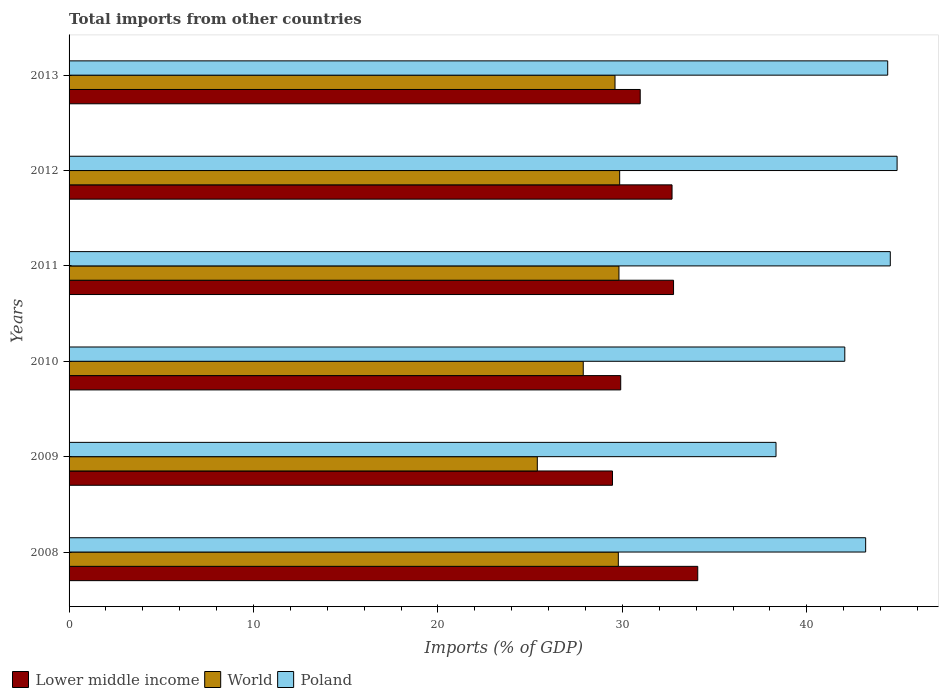How many different coloured bars are there?
Ensure brevity in your answer.  3. How many groups of bars are there?
Make the answer very short. 6. How many bars are there on the 2nd tick from the top?
Keep it short and to the point. 3. How many bars are there on the 3rd tick from the bottom?
Make the answer very short. 3. In how many cases, is the number of bars for a given year not equal to the number of legend labels?
Offer a very short reply. 0. What is the total imports in Lower middle income in 2008?
Provide a short and direct response. 34.09. Across all years, what is the maximum total imports in World?
Offer a very short reply. 29.85. Across all years, what is the minimum total imports in Poland?
Offer a terse response. 38.33. In which year was the total imports in Poland minimum?
Provide a succinct answer. 2009. What is the total total imports in Lower middle income in the graph?
Keep it short and to the point. 189.9. What is the difference between the total imports in World in 2009 and that in 2012?
Provide a succinct answer. -4.47. What is the difference between the total imports in Lower middle income in 2011 and the total imports in World in 2008?
Keep it short and to the point. 2.99. What is the average total imports in Lower middle income per year?
Provide a short and direct response. 31.65. In the year 2012, what is the difference between the total imports in Poland and total imports in World?
Ensure brevity in your answer.  15.04. In how many years, is the total imports in World greater than 16 %?
Give a very brief answer. 6. What is the ratio of the total imports in Lower middle income in 2011 to that in 2013?
Give a very brief answer. 1.06. Is the difference between the total imports in Poland in 2011 and 2012 greater than the difference between the total imports in World in 2011 and 2012?
Your answer should be compact. No. What is the difference between the highest and the second highest total imports in Poland?
Your answer should be compact. 0.37. What is the difference between the highest and the lowest total imports in Poland?
Your answer should be compact. 6.57. Is the sum of the total imports in Lower middle income in 2008 and 2010 greater than the maximum total imports in Poland across all years?
Ensure brevity in your answer.  Yes. What does the 3rd bar from the top in 2013 represents?
Your response must be concise. Lower middle income. Is it the case that in every year, the sum of the total imports in Lower middle income and total imports in World is greater than the total imports in Poland?
Ensure brevity in your answer.  Yes. Are all the bars in the graph horizontal?
Offer a very short reply. Yes. How many years are there in the graph?
Keep it short and to the point. 6. What is the difference between two consecutive major ticks on the X-axis?
Keep it short and to the point. 10. Does the graph contain any zero values?
Keep it short and to the point. No. How are the legend labels stacked?
Ensure brevity in your answer.  Horizontal. What is the title of the graph?
Your answer should be very brief. Total imports from other countries. What is the label or title of the X-axis?
Keep it short and to the point. Imports (% of GDP). What is the label or title of the Y-axis?
Provide a succinct answer. Years. What is the Imports (% of GDP) in Lower middle income in 2008?
Provide a succinct answer. 34.09. What is the Imports (% of GDP) in World in 2008?
Give a very brief answer. 29.78. What is the Imports (% of GDP) of Poland in 2008?
Offer a terse response. 43.19. What is the Imports (% of GDP) in Lower middle income in 2009?
Offer a terse response. 29.46. What is the Imports (% of GDP) of World in 2009?
Your answer should be very brief. 25.39. What is the Imports (% of GDP) of Poland in 2009?
Offer a very short reply. 38.33. What is the Imports (% of GDP) of Lower middle income in 2010?
Your answer should be very brief. 29.91. What is the Imports (% of GDP) of World in 2010?
Ensure brevity in your answer.  27.88. What is the Imports (% of GDP) of Poland in 2010?
Provide a succinct answer. 42.06. What is the Imports (% of GDP) of Lower middle income in 2011?
Offer a very short reply. 32.77. What is the Imports (% of GDP) of World in 2011?
Provide a short and direct response. 29.82. What is the Imports (% of GDP) in Poland in 2011?
Your answer should be compact. 44.53. What is the Imports (% of GDP) in Lower middle income in 2012?
Offer a terse response. 32.69. What is the Imports (% of GDP) of World in 2012?
Provide a short and direct response. 29.85. What is the Imports (% of GDP) in Poland in 2012?
Provide a succinct answer. 44.9. What is the Imports (% of GDP) of Lower middle income in 2013?
Provide a short and direct response. 30.97. What is the Imports (% of GDP) of World in 2013?
Provide a short and direct response. 29.6. What is the Imports (% of GDP) of Poland in 2013?
Provide a short and direct response. 44.39. Across all years, what is the maximum Imports (% of GDP) of Lower middle income?
Your answer should be very brief. 34.09. Across all years, what is the maximum Imports (% of GDP) of World?
Keep it short and to the point. 29.85. Across all years, what is the maximum Imports (% of GDP) in Poland?
Provide a succinct answer. 44.9. Across all years, what is the minimum Imports (% of GDP) in Lower middle income?
Offer a very short reply. 29.46. Across all years, what is the minimum Imports (% of GDP) in World?
Offer a terse response. 25.39. Across all years, what is the minimum Imports (% of GDP) of Poland?
Give a very brief answer. 38.33. What is the total Imports (% of GDP) of Lower middle income in the graph?
Make the answer very short. 189.9. What is the total Imports (% of GDP) in World in the graph?
Your answer should be very brief. 172.32. What is the total Imports (% of GDP) in Poland in the graph?
Ensure brevity in your answer.  257.39. What is the difference between the Imports (% of GDP) of Lower middle income in 2008 and that in 2009?
Keep it short and to the point. 4.62. What is the difference between the Imports (% of GDP) in World in 2008 and that in 2009?
Your answer should be very brief. 4.39. What is the difference between the Imports (% of GDP) in Poland in 2008 and that in 2009?
Your answer should be very brief. 4.86. What is the difference between the Imports (% of GDP) in Lower middle income in 2008 and that in 2010?
Your response must be concise. 4.18. What is the difference between the Imports (% of GDP) in World in 2008 and that in 2010?
Make the answer very short. 1.9. What is the difference between the Imports (% of GDP) in Poland in 2008 and that in 2010?
Your response must be concise. 1.13. What is the difference between the Imports (% of GDP) in Lower middle income in 2008 and that in 2011?
Your answer should be compact. 1.31. What is the difference between the Imports (% of GDP) of World in 2008 and that in 2011?
Give a very brief answer. -0.03. What is the difference between the Imports (% of GDP) in Poland in 2008 and that in 2011?
Offer a terse response. -1.34. What is the difference between the Imports (% of GDP) in Lower middle income in 2008 and that in 2012?
Offer a very short reply. 1.39. What is the difference between the Imports (% of GDP) of World in 2008 and that in 2012?
Ensure brevity in your answer.  -0.07. What is the difference between the Imports (% of GDP) in Poland in 2008 and that in 2012?
Your answer should be compact. -1.7. What is the difference between the Imports (% of GDP) in Lower middle income in 2008 and that in 2013?
Offer a very short reply. 3.12. What is the difference between the Imports (% of GDP) of World in 2008 and that in 2013?
Offer a terse response. 0.18. What is the difference between the Imports (% of GDP) in Poland in 2008 and that in 2013?
Your answer should be very brief. -1.2. What is the difference between the Imports (% of GDP) of Lower middle income in 2009 and that in 2010?
Your response must be concise. -0.45. What is the difference between the Imports (% of GDP) of World in 2009 and that in 2010?
Provide a short and direct response. -2.49. What is the difference between the Imports (% of GDP) in Poland in 2009 and that in 2010?
Your answer should be compact. -3.73. What is the difference between the Imports (% of GDP) of Lower middle income in 2009 and that in 2011?
Ensure brevity in your answer.  -3.31. What is the difference between the Imports (% of GDP) in World in 2009 and that in 2011?
Provide a succinct answer. -4.43. What is the difference between the Imports (% of GDP) in Poland in 2009 and that in 2011?
Give a very brief answer. -6.2. What is the difference between the Imports (% of GDP) of Lower middle income in 2009 and that in 2012?
Offer a terse response. -3.23. What is the difference between the Imports (% of GDP) of World in 2009 and that in 2012?
Give a very brief answer. -4.47. What is the difference between the Imports (% of GDP) of Poland in 2009 and that in 2012?
Make the answer very short. -6.57. What is the difference between the Imports (% of GDP) of Lower middle income in 2009 and that in 2013?
Offer a very short reply. -1.5. What is the difference between the Imports (% of GDP) in World in 2009 and that in 2013?
Provide a succinct answer. -4.21. What is the difference between the Imports (% of GDP) in Poland in 2009 and that in 2013?
Give a very brief answer. -6.06. What is the difference between the Imports (% of GDP) in Lower middle income in 2010 and that in 2011?
Make the answer very short. -2.86. What is the difference between the Imports (% of GDP) in World in 2010 and that in 2011?
Offer a terse response. -1.94. What is the difference between the Imports (% of GDP) in Poland in 2010 and that in 2011?
Provide a short and direct response. -2.47. What is the difference between the Imports (% of GDP) of Lower middle income in 2010 and that in 2012?
Make the answer very short. -2.78. What is the difference between the Imports (% of GDP) of World in 2010 and that in 2012?
Make the answer very short. -1.97. What is the difference between the Imports (% of GDP) of Poland in 2010 and that in 2012?
Offer a very short reply. -2.84. What is the difference between the Imports (% of GDP) in Lower middle income in 2010 and that in 2013?
Offer a very short reply. -1.06. What is the difference between the Imports (% of GDP) of World in 2010 and that in 2013?
Give a very brief answer. -1.72. What is the difference between the Imports (% of GDP) of Poland in 2010 and that in 2013?
Provide a succinct answer. -2.33. What is the difference between the Imports (% of GDP) in Lower middle income in 2011 and that in 2012?
Your answer should be very brief. 0.08. What is the difference between the Imports (% of GDP) in World in 2011 and that in 2012?
Provide a succinct answer. -0.04. What is the difference between the Imports (% of GDP) of Poland in 2011 and that in 2012?
Provide a succinct answer. -0.37. What is the difference between the Imports (% of GDP) in Lower middle income in 2011 and that in 2013?
Your answer should be very brief. 1.81. What is the difference between the Imports (% of GDP) of World in 2011 and that in 2013?
Give a very brief answer. 0.21. What is the difference between the Imports (% of GDP) in Poland in 2011 and that in 2013?
Offer a very short reply. 0.14. What is the difference between the Imports (% of GDP) of Lower middle income in 2012 and that in 2013?
Offer a terse response. 1.73. What is the difference between the Imports (% of GDP) of World in 2012 and that in 2013?
Your answer should be compact. 0.25. What is the difference between the Imports (% of GDP) of Poland in 2012 and that in 2013?
Your response must be concise. 0.51. What is the difference between the Imports (% of GDP) in Lower middle income in 2008 and the Imports (% of GDP) in World in 2009?
Offer a terse response. 8.7. What is the difference between the Imports (% of GDP) in Lower middle income in 2008 and the Imports (% of GDP) in Poland in 2009?
Offer a terse response. -4.24. What is the difference between the Imports (% of GDP) in World in 2008 and the Imports (% of GDP) in Poland in 2009?
Your answer should be compact. -8.55. What is the difference between the Imports (% of GDP) in Lower middle income in 2008 and the Imports (% of GDP) in World in 2010?
Make the answer very short. 6.21. What is the difference between the Imports (% of GDP) in Lower middle income in 2008 and the Imports (% of GDP) in Poland in 2010?
Your answer should be compact. -7.97. What is the difference between the Imports (% of GDP) in World in 2008 and the Imports (% of GDP) in Poland in 2010?
Make the answer very short. -12.28. What is the difference between the Imports (% of GDP) in Lower middle income in 2008 and the Imports (% of GDP) in World in 2011?
Ensure brevity in your answer.  4.27. What is the difference between the Imports (% of GDP) in Lower middle income in 2008 and the Imports (% of GDP) in Poland in 2011?
Your answer should be compact. -10.44. What is the difference between the Imports (% of GDP) in World in 2008 and the Imports (% of GDP) in Poland in 2011?
Your answer should be compact. -14.75. What is the difference between the Imports (% of GDP) of Lower middle income in 2008 and the Imports (% of GDP) of World in 2012?
Provide a short and direct response. 4.23. What is the difference between the Imports (% of GDP) of Lower middle income in 2008 and the Imports (% of GDP) of Poland in 2012?
Provide a succinct answer. -10.81. What is the difference between the Imports (% of GDP) of World in 2008 and the Imports (% of GDP) of Poland in 2012?
Provide a succinct answer. -15.11. What is the difference between the Imports (% of GDP) in Lower middle income in 2008 and the Imports (% of GDP) in World in 2013?
Your answer should be compact. 4.49. What is the difference between the Imports (% of GDP) in Lower middle income in 2008 and the Imports (% of GDP) in Poland in 2013?
Make the answer very short. -10.3. What is the difference between the Imports (% of GDP) in World in 2008 and the Imports (% of GDP) in Poland in 2013?
Offer a terse response. -14.61. What is the difference between the Imports (% of GDP) in Lower middle income in 2009 and the Imports (% of GDP) in World in 2010?
Keep it short and to the point. 1.59. What is the difference between the Imports (% of GDP) of Lower middle income in 2009 and the Imports (% of GDP) of Poland in 2010?
Offer a very short reply. -12.6. What is the difference between the Imports (% of GDP) in World in 2009 and the Imports (% of GDP) in Poland in 2010?
Provide a short and direct response. -16.67. What is the difference between the Imports (% of GDP) of Lower middle income in 2009 and the Imports (% of GDP) of World in 2011?
Your answer should be very brief. -0.35. What is the difference between the Imports (% of GDP) in Lower middle income in 2009 and the Imports (% of GDP) in Poland in 2011?
Give a very brief answer. -15.06. What is the difference between the Imports (% of GDP) in World in 2009 and the Imports (% of GDP) in Poland in 2011?
Make the answer very short. -19.14. What is the difference between the Imports (% of GDP) of Lower middle income in 2009 and the Imports (% of GDP) of World in 2012?
Offer a terse response. -0.39. What is the difference between the Imports (% of GDP) of Lower middle income in 2009 and the Imports (% of GDP) of Poland in 2012?
Keep it short and to the point. -15.43. What is the difference between the Imports (% of GDP) in World in 2009 and the Imports (% of GDP) in Poland in 2012?
Your answer should be very brief. -19.51. What is the difference between the Imports (% of GDP) in Lower middle income in 2009 and the Imports (% of GDP) in World in 2013?
Your answer should be compact. -0.14. What is the difference between the Imports (% of GDP) in Lower middle income in 2009 and the Imports (% of GDP) in Poland in 2013?
Your response must be concise. -14.92. What is the difference between the Imports (% of GDP) in World in 2009 and the Imports (% of GDP) in Poland in 2013?
Offer a terse response. -19. What is the difference between the Imports (% of GDP) of Lower middle income in 2010 and the Imports (% of GDP) of World in 2011?
Make the answer very short. 0.1. What is the difference between the Imports (% of GDP) in Lower middle income in 2010 and the Imports (% of GDP) in Poland in 2011?
Your response must be concise. -14.62. What is the difference between the Imports (% of GDP) of World in 2010 and the Imports (% of GDP) of Poland in 2011?
Keep it short and to the point. -16.65. What is the difference between the Imports (% of GDP) of Lower middle income in 2010 and the Imports (% of GDP) of World in 2012?
Provide a succinct answer. 0.06. What is the difference between the Imports (% of GDP) in Lower middle income in 2010 and the Imports (% of GDP) in Poland in 2012?
Ensure brevity in your answer.  -14.98. What is the difference between the Imports (% of GDP) of World in 2010 and the Imports (% of GDP) of Poland in 2012?
Ensure brevity in your answer.  -17.02. What is the difference between the Imports (% of GDP) of Lower middle income in 2010 and the Imports (% of GDP) of World in 2013?
Ensure brevity in your answer.  0.31. What is the difference between the Imports (% of GDP) of Lower middle income in 2010 and the Imports (% of GDP) of Poland in 2013?
Offer a very short reply. -14.48. What is the difference between the Imports (% of GDP) in World in 2010 and the Imports (% of GDP) in Poland in 2013?
Ensure brevity in your answer.  -16.51. What is the difference between the Imports (% of GDP) of Lower middle income in 2011 and the Imports (% of GDP) of World in 2012?
Provide a succinct answer. 2.92. What is the difference between the Imports (% of GDP) in Lower middle income in 2011 and the Imports (% of GDP) in Poland in 2012?
Make the answer very short. -12.12. What is the difference between the Imports (% of GDP) of World in 2011 and the Imports (% of GDP) of Poland in 2012?
Your answer should be very brief. -15.08. What is the difference between the Imports (% of GDP) of Lower middle income in 2011 and the Imports (% of GDP) of World in 2013?
Your answer should be compact. 3.17. What is the difference between the Imports (% of GDP) in Lower middle income in 2011 and the Imports (% of GDP) in Poland in 2013?
Offer a very short reply. -11.61. What is the difference between the Imports (% of GDP) of World in 2011 and the Imports (% of GDP) of Poland in 2013?
Offer a terse response. -14.57. What is the difference between the Imports (% of GDP) of Lower middle income in 2012 and the Imports (% of GDP) of World in 2013?
Provide a succinct answer. 3.09. What is the difference between the Imports (% of GDP) of Lower middle income in 2012 and the Imports (% of GDP) of Poland in 2013?
Your answer should be very brief. -11.69. What is the difference between the Imports (% of GDP) of World in 2012 and the Imports (% of GDP) of Poland in 2013?
Make the answer very short. -14.53. What is the average Imports (% of GDP) of Lower middle income per year?
Your response must be concise. 31.65. What is the average Imports (% of GDP) in World per year?
Offer a terse response. 28.72. What is the average Imports (% of GDP) of Poland per year?
Make the answer very short. 42.9. In the year 2008, what is the difference between the Imports (% of GDP) of Lower middle income and Imports (% of GDP) of World?
Offer a very short reply. 4.31. In the year 2008, what is the difference between the Imports (% of GDP) of Lower middle income and Imports (% of GDP) of Poland?
Ensure brevity in your answer.  -9.1. In the year 2008, what is the difference between the Imports (% of GDP) in World and Imports (% of GDP) in Poland?
Your answer should be compact. -13.41. In the year 2009, what is the difference between the Imports (% of GDP) of Lower middle income and Imports (% of GDP) of World?
Your answer should be compact. 4.08. In the year 2009, what is the difference between the Imports (% of GDP) in Lower middle income and Imports (% of GDP) in Poland?
Offer a very short reply. -8.87. In the year 2009, what is the difference between the Imports (% of GDP) in World and Imports (% of GDP) in Poland?
Provide a short and direct response. -12.94. In the year 2010, what is the difference between the Imports (% of GDP) in Lower middle income and Imports (% of GDP) in World?
Give a very brief answer. 2.03. In the year 2010, what is the difference between the Imports (% of GDP) in Lower middle income and Imports (% of GDP) in Poland?
Your answer should be very brief. -12.15. In the year 2010, what is the difference between the Imports (% of GDP) in World and Imports (% of GDP) in Poland?
Offer a terse response. -14.18. In the year 2011, what is the difference between the Imports (% of GDP) of Lower middle income and Imports (% of GDP) of World?
Offer a very short reply. 2.96. In the year 2011, what is the difference between the Imports (% of GDP) of Lower middle income and Imports (% of GDP) of Poland?
Your answer should be compact. -11.75. In the year 2011, what is the difference between the Imports (% of GDP) in World and Imports (% of GDP) in Poland?
Provide a succinct answer. -14.71. In the year 2012, what is the difference between the Imports (% of GDP) of Lower middle income and Imports (% of GDP) of World?
Give a very brief answer. 2.84. In the year 2012, what is the difference between the Imports (% of GDP) of Lower middle income and Imports (% of GDP) of Poland?
Your answer should be compact. -12.2. In the year 2012, what is the difference between the Imports (% of GDP) of World and Imports (% of GDP) of Poland?
Ensure brevity in your answer.  -15.04. In the year 2013, what is the difference between the Imports (% of GDP) in Lower middle income and Imports (% of GDP) in World?
Ensure brevity in your answer.  1.37. In the year 2013, what is the difference between the Imports (% of GDP) of Lower middle income and Imports (% of GDP) of Poland?
Provide a short and direct response. -13.42. In the year 2013, what is the difference between the Imports (% of GDP) in World and Imports (% of GDP) in Poland?
Ensure brevity in your answer.  -14.79. What is the ratio of the Imports (% of GDP) of Lower middle income in 2008 to that in 2009?
Keep it short and to the point. 1.16. What is the ratio of the Imports (% of GDP) in World in 2008 to that in 2009?
Ensure brevity in your answer.  1.17. What is the ratio of the Imports (% of GDP) in Poland in 2008 to that in 2009?
Your answer should be very brief. 1.13. What is the ratio of the Imports (% of GDP) of Lower middle income in 2008 to that in 2010?
Provide a short and direct response. 1.14. What is the ratio of the Imports (% of GDP) in World in 2008 to that in 2010?
Your answer should be very brief. 1.07. What is the ratio of the Imports (% of GDP) in Poland in 2008 to that in 2010?
Offer a very short reply. 1.03. What is the ratio of the Imports (% of GDP) of Lower middle income in 2008 to that in 2011?
Give a very brief answer. 1.04. What is the ratio of the Imports (% of GDP) of Lower middle income in 2008 to that in 2012?
Offer a very short reply. 1.04. What is the ratio of the Imports (% of GDP) in Lower middle income in 2008 to that in 2013?
Make the answer very short. 1.1. What is the ratio of the Imports (% of GDP) in World in 2008 to that in 2013?
Make the answer very short. 1.01. What is the ratio of the Imports (% of GDP) in Poland in 2008 to that in 2013?
Keep it short and to the point. 0.97. What is the ratio of the Imports (% of GDP) in Lower middle income in 2009 to that in 2010?
Your response must be concise. 0.99. What is the ratio of the Imports (% of GDP) of World in 2009 to that in 2010?
Your answer should be compact. 0.91. What is the ratio of the Imports (% of GDP) in Poland in 2009 to that in 2010?
Provide a short and direct response. 0.91. What is the ratio of the Imports (% of GDP) in Lower middle income in 2009 to that in 2011?
Keep it short and to the point. 0.9. What is the ratio of the Imports (% of GDP) in World in 2009 to that in 2011?
Provide a succinct answer. 0.85. What is the ratio of the Imports (% of GDP) in Poland in 2009 to that in 2011?
Keep it short and to the point. 0.86. What is the ratio of the Imports (% of GDP) of Lower middle income in 2009 to that in 2012?
Offer a very short reply. 0.9. What is the ratio of the Imports (% of GDP) of World in 2009 to that in 2012?
Give a very brief answer. 0.85. What is the ratio of the Imports (% of GDP) of Poland in 2009 to that in 2012?
Your answer should be very brief. 0.85. What is the ratio of the Imports (% of GDP) in Lower middle income in 2009 to that in 2013?
Offer a terse response. 0.95. What is the ratio of the Imports (% of GDP) in World in 2009 to that in 2013?
Your response must be concise. 0.86. What is the ratio of the Imports (% of GDP) of Poland in 2009 to that in 2013?
Your answer should be compact. 0.86. What is the ratio of the Imports (% of GDP) in Lower middle income in 2010 to that in 2011?
Provide a short and direct response. 0.91. What is the ratio of the Imports (% of GDP) in World in 2010 to that in 2011?
Give a very brief answer. 0.94. What is the ratio of the Imports (% of GDP) of Poland in 2010 to that in 2011?
Provide a succinct answer. 0.94. What is the ratio of the Imports (% of GDP) in Lower middle income in 2010 to that in 2012?
Ensure brevity in your answer.  0.91. What is the ratio of the Imports (% of GDP) in World in 2010 to that in 2012?
Provide a short and direct response. 0.93. What is the ratio of the Imports (% of GDP) of Poland in 2010 to that in 2012?
Ensure brevity in your answer.  0.94. What is the ratio of the Imports (% of GDP) of Lower middle income in 2010 to that in 2013?
Your response must be concise. 0.97. What is the ratio of the Imports (% of GDP) in World in 2010 to that in 2013?
Provide a succinct answer. 0.94. What is the ratio of the Imports (% of GDP) in Poland in 2010 to that in 2013?
Ensure brevity in your answer.  0.95. What is the ratio of the Imports (% of GDP) of Lower middle income in 2011 to that in 2012?
Keep it short and to the point. 1. What is the ratio of the Imports (% of GDP) of Lower middle income in 2011 to that in 2013?
Your response must be concise. 1.06. What is the ratio of the Imports (% of GDP) of World in 2011 to that in 2013?
Offer a very short reply. 1.01. What is the ratio of the Imports (% of GDP) of Lower middle income in 2012 to that in 2013?
Provide a short and direct response. 1.06. What is the ratio of the Imports (% of GDP) of World in 2012 to that in 2013?
Provide a succinct answer. 1.01. What is the ratio of the Imports (% of GDP) in Poland in 2012 to that in 2013?
Offer a terse response. 1.01. What is the difference between the highest and the second highest Imports (% of GDP) of Lower middle income?
Your answer should be compact. 1.31. What is the difference between the highest and the second highest Imports (% of GDP) in World?
Your answer should be very brief. 0.04. What is the difference between the highest and the second highest Imports (% of GDP) of Poland?
Offer a terse response. 0.37. What is the difference between the highest and the lowest Imports (% of GDP) in Lower middle income?
Offer a terse response. 4.62. What is the difference between the highest and the lowest Imports (% of GDP) of World?
Offer a very short reply. 4.47. What is the difference between the highest and the lowest Imports (% of GDP) of Poland?
Provide a succinct answer. 6.57. 